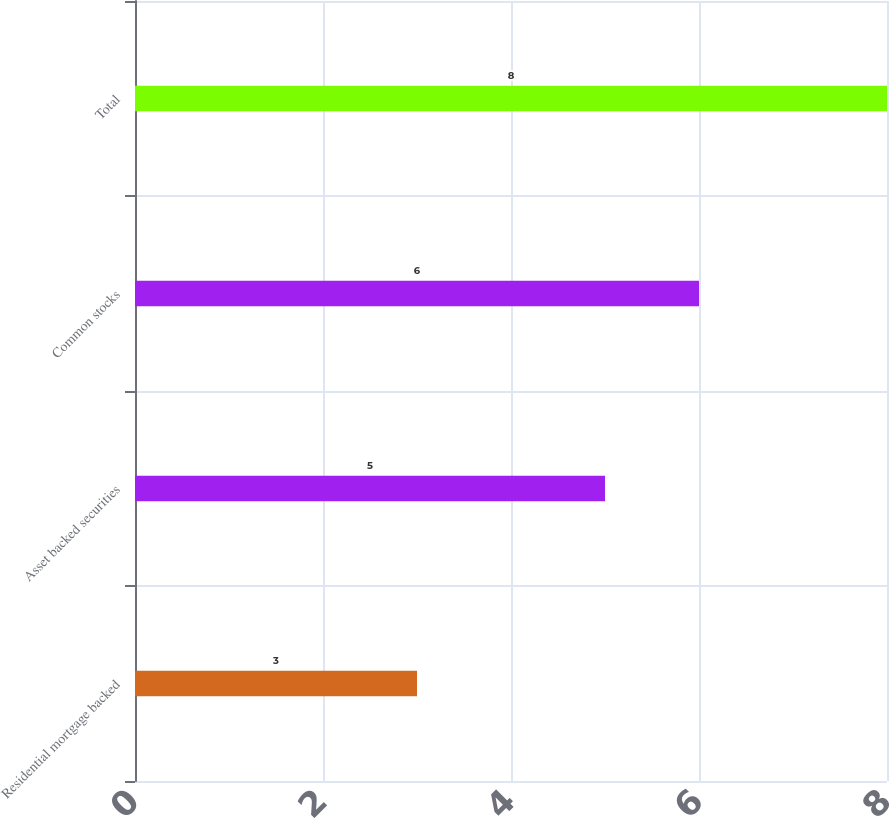Convert chart to OTSL. <chart><loc_0><loc_0><loc_500><loc_500><bar_chart><fcel>Residential mortgage backed<fcel>Asset backed securities<fcel>Common stocks<fcel>Total<nl><fcel>3<fcel>5<fcel>6<fcel>8<nl></chart> 